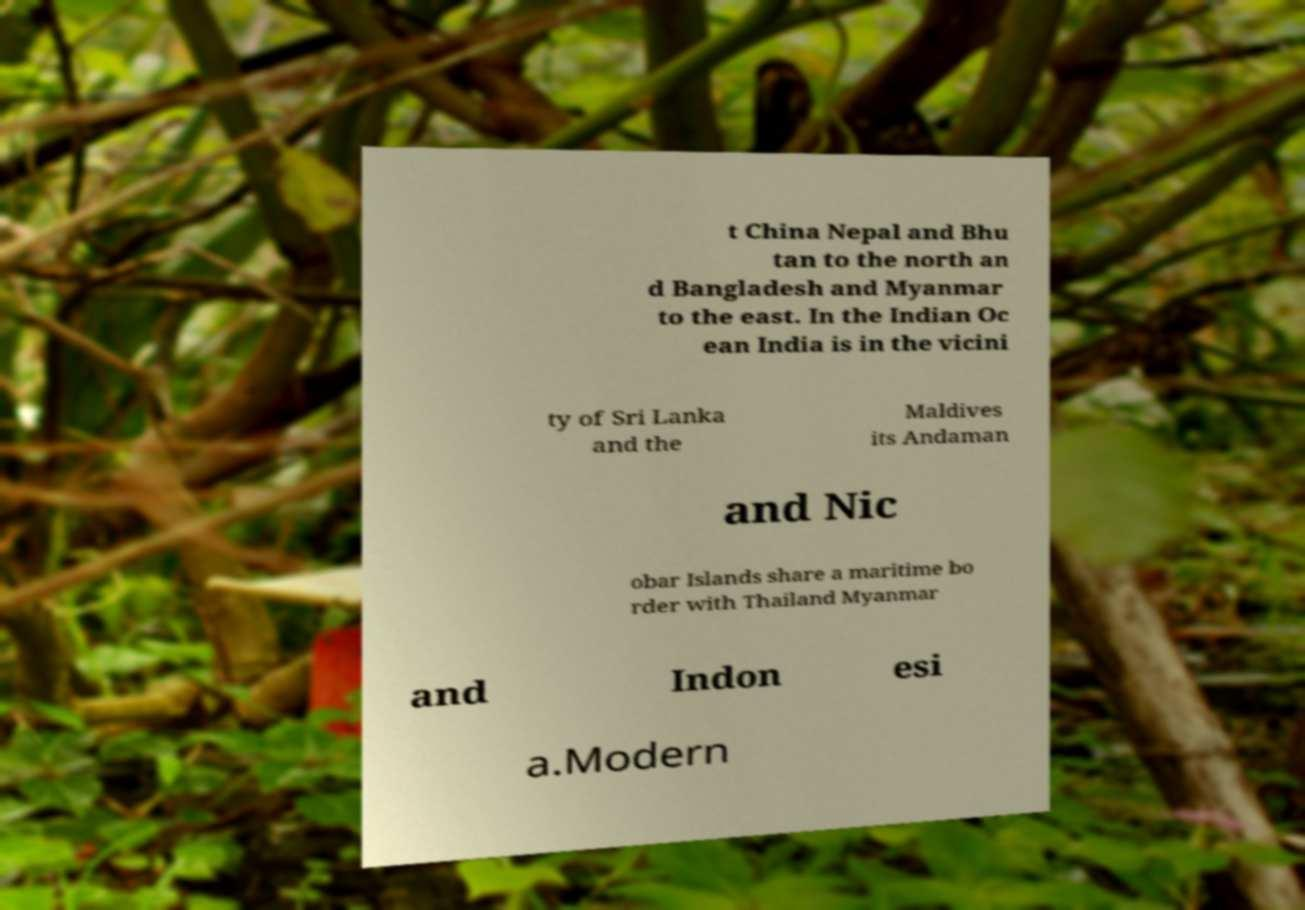Can you accurately transcribe the text from the provided image for me? t China Nepal and Bhu tan to the north an d Bangladesh and Myanmar to the east. In the Indian Oc ean India is in the vicini ty of Sri Lanka and the Maldives its Andaman and Nic obar Islands share a maritime bo rder with Thailand Myanmar and Indon esi a.Modern 